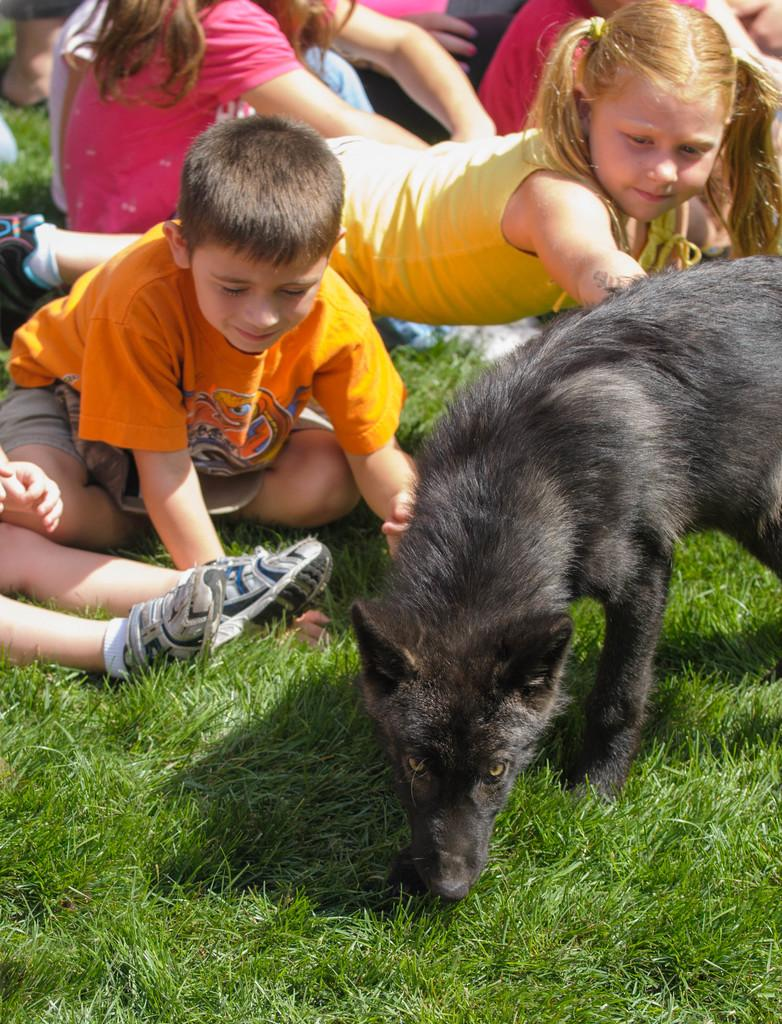What is present in the image? There are kids and a dog in the image. Where are the kids located in the image? The kids are sitting on the grass. What type of cap is the dog wearing in the image? There is no cap present on the dog in the image. Where is the playground located in the image? There is no playground present in the image. --- 